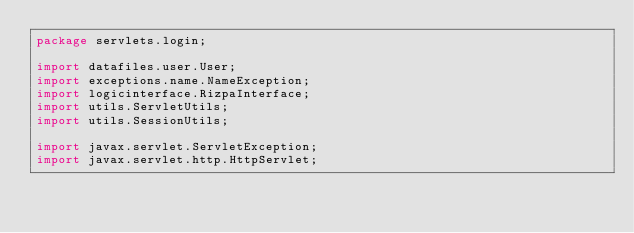<code> <loc_0><loc_0><loc_500><loc_500><_Java_>package servlets.login;

import datafiles.user.User;
import exceptions.name.NameException;
import logicinterface.RizpaInterface;
import utils.ServletUtils;
import utils.SessionUtils;

import javax.servlet.ServletException;
import javax.servlet.http.HttpServlet;</code> 